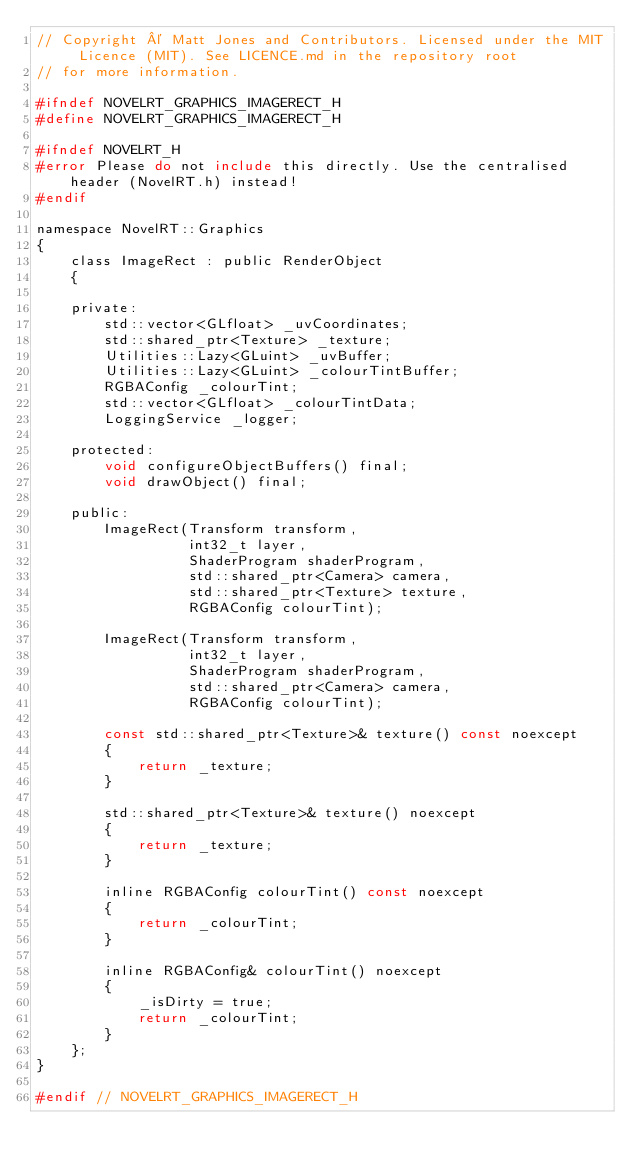<code> <loc_0><loc_0><loc_500><loc_500><_C_>// Copyright © Matt Jones and Contributors. Licensed under the MIT Licence (MIT). See LICENCE.md in the repository root
// for more information.

#ifndef NOVELRT_GRAPHICS_IMAGERECT_H
#define NOVELRT_GRAPHICS_IMAGERECT_H

#ifndef NOVELRT_H
#error Please do not include this directly. Use the centralised header (NovelRT.h) instead!
#endif

namespace NovelRT::Graphics
{
    class ImageRect : public RenderObject
    {

    private:
        std::vector<GLfloat> _uvCoordinates;
        std::shared_ptr<Texture> _texture;
        Utilities::Lazy<GLuint> _uvBuffer;
        Utilities::Lazy<GLuint> _colourTintBuffer;
        RGBAConfig _colourTint;
        std::vector<GLfloat> _colourTintData;
        LoggingService _logger;

    protected:
        void configureObjectBuffers() final;
        void drawObject() final;

    public:
        ImageRect(Transform transform,
                  int32_t layer,
                  ShaderProgram shaderProgram,
                  std::shared_ptr<Camera> camera,
                  std::shared_ptr<Texture> texture,
                  RGBAConfig colourTint);

        ImageRect(Transform transform,
                  int32_t layer,
                  ShaderProgram shaderProgram,
                  std::shared_ptr<Camera> camera,
                  RGBAConfig colourTint);

        const std::shared_ptr<Texture>& texture() const noexcept
        {
            return _texture;
        }

        std::shared_ptr<Texture>& texture() noexcept
        {
            return _texture;
        }

        inline RGBAConfig colourTint() const noexcept
        {
            return _colourTint;
        }

        inline RGBAConfig& colourTint() noexcept
        {
            _isDirty = true;
            return _colourTint;
        }
    };
}

#endif // NOVELRT_GRAPHICS_IMAGERECT_H
</code> 